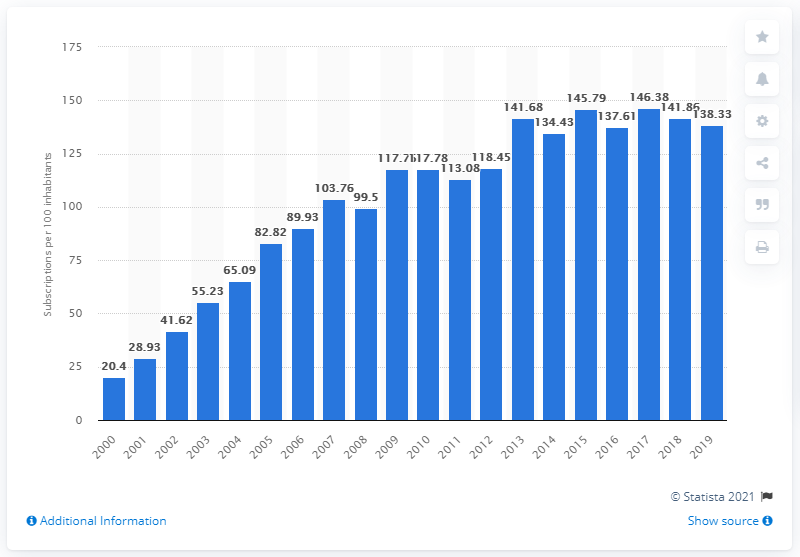Identify some key points in this picture. In Qatar, the number of mobile subscriptions per 100 people increased from 138.33 in 2000 to 188.53 in 2019. 